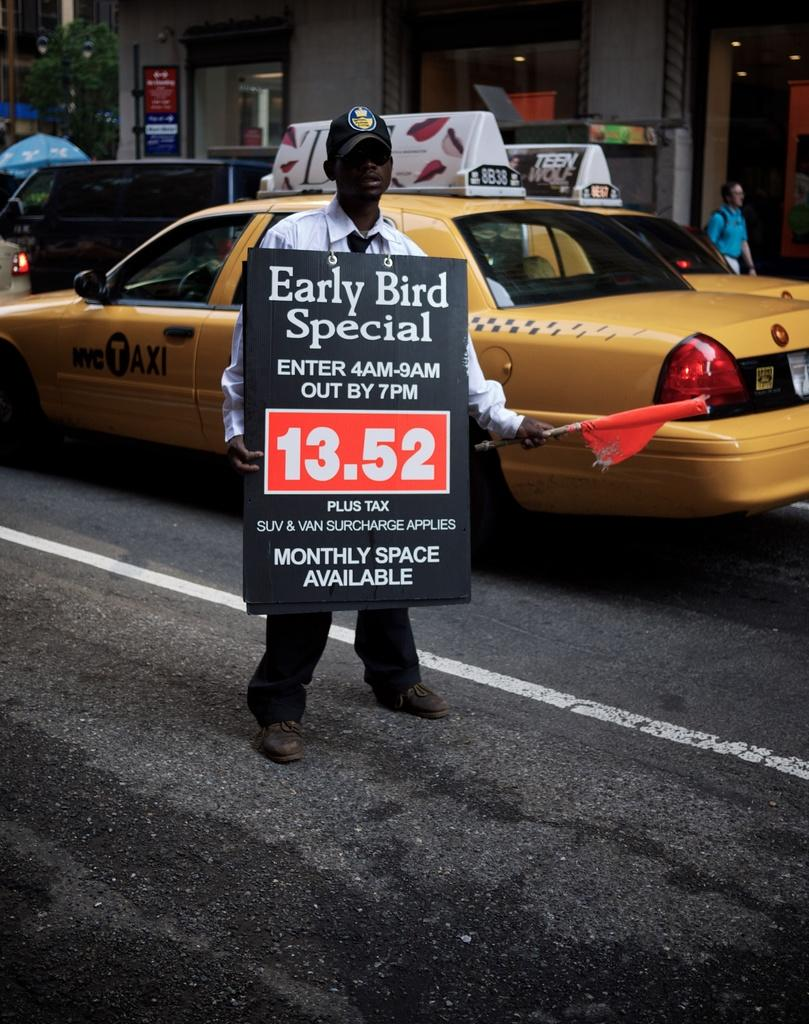Provide a one-sentence caption for the provided image. The man is wearing a sign advertising an early bird special. 